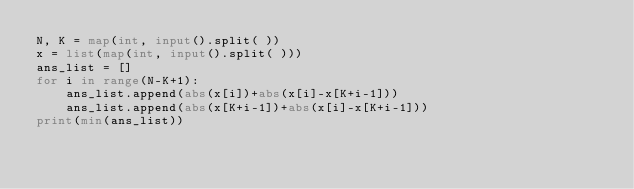<code> <loc_0><loc_0><loc_500><loc_500><_Python_>N, K = map(int, input().split( ))
x = list(map(int, input().split( )))
ans_list = []
for i in range(N-K+1):
	ans_list.append(abs(x[i])+abs(x[i]-x[K+i-1]))
	ans_list.append(abs(x[K+i-1])+abs(x[i]-x[K+i-1]))
print(min(ans_list))
	</code> 